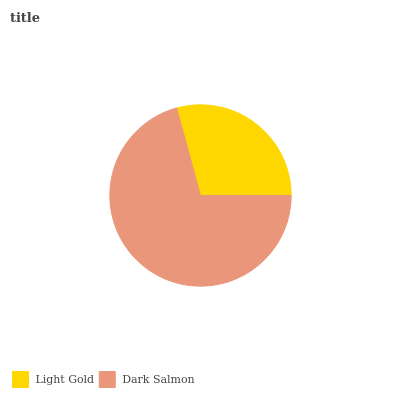Is Light Gold the minimum?
Answer yes or no. Yes. Is Dark Salmon the maximum?
Answer yes or no. Yes. Is Dark Salmon the minimum?
Answer yes or no. No. Is Dark Salmon greater than Light Gold?
Answer yes or no. Yes. Is Light Gold less than Dark Salmon?
Answer yes or no. Yes. Is Light Gold greater than Dark Salmon?
Answer yes or no. No. Is Dark Salmon less than Light Gold?
Answer yes or no. No. Is Dark Salmon the high median?
Answer yes or no. Yes. Is Light Gold the low median?
Answer yes or no. Yes. Is Light Gold the high median?
Answer yes or no. No. Is Dark Salmon the low median?
Answer yes or no. No. 